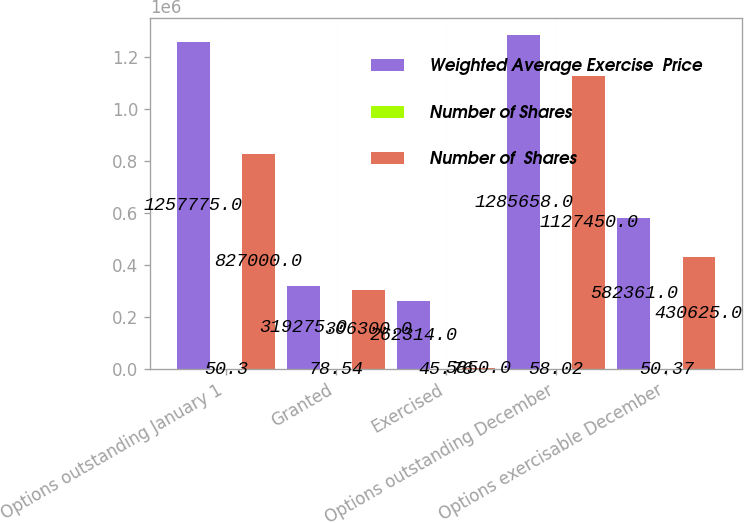<chart> <loc_0><loc_0><loc_500><loc_500><stacked_bar_chart><ecel><fcel>Options outstanding January 1<fcel>Granted<fcel>Exercised<fcel>Options outstanding December<fcel>Options exercisable December<nl><fcel>Weighted Average Exercise  Price<fcel>1.25778e+06<fcel>319275<fcel>262314<fcel>1.28566e+06<fcel>582361<nl><fcel>Number of Shares<fcel>50.3<fcel>78.54<fcel>45.76<fcel>58.02<fcel>50.37<nl><fcel>Number of  Shares<fcel>827000<fcel>306300<fcel>5850<fcel>1.12745e+06<fcel>430625<nl></chart> 